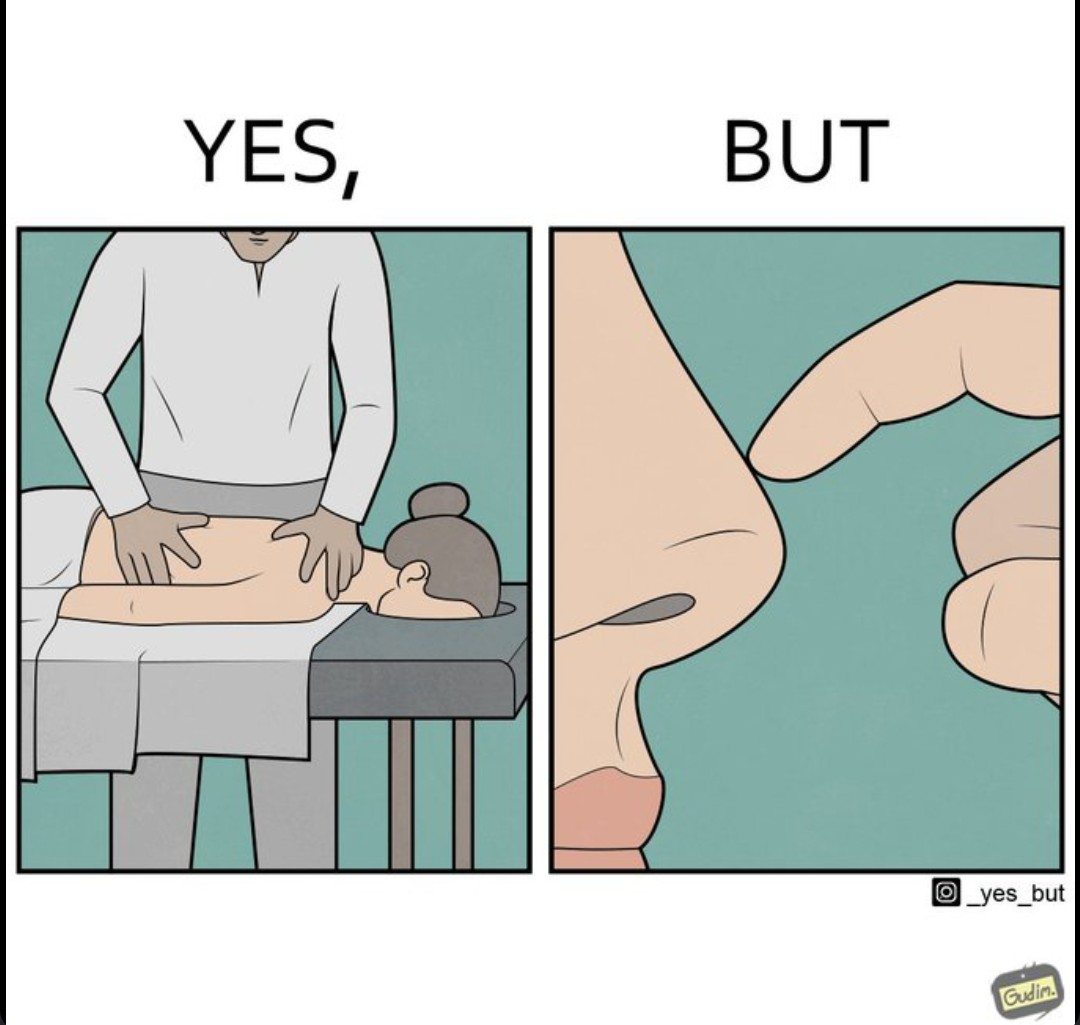What makes this image funny or satirical? The images are funny since even though a woman goes for a full body massage expecting it to soothe her whole body, the design of a massage table is such that no matter how badly her nose itches, she cannot scratch it to soothe herself 